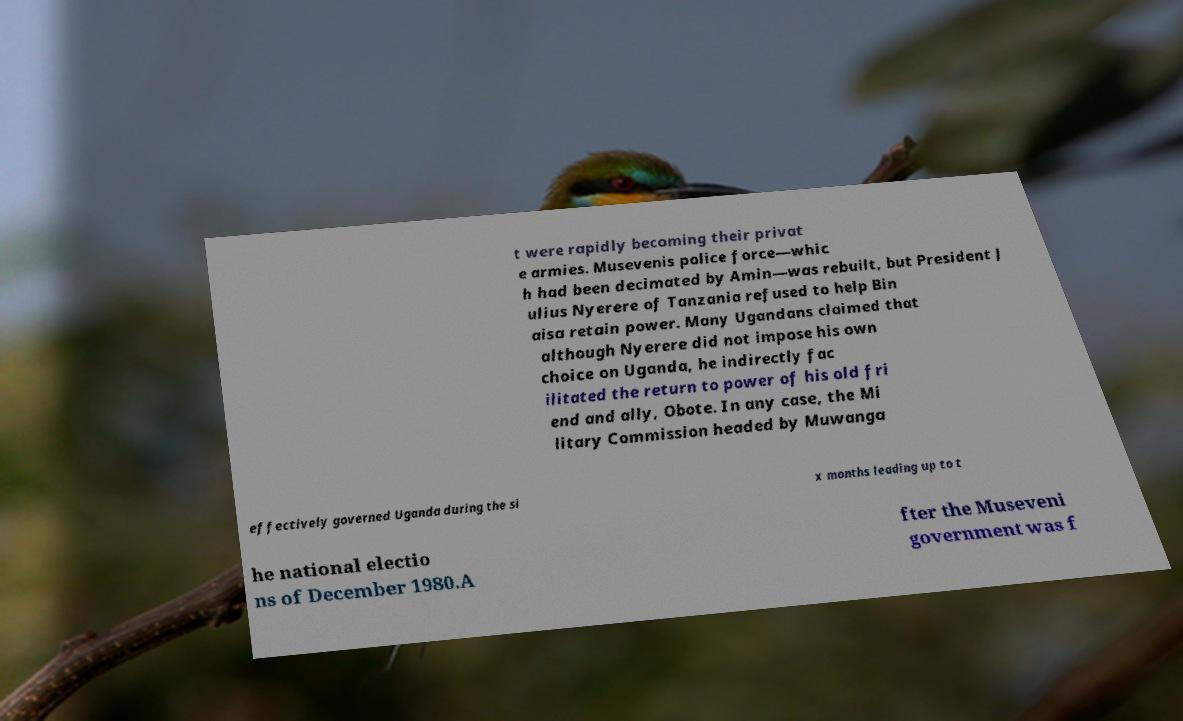Could you assist in decoding the text presented in this image and type it out clearly? t were rapidly becoming their privat e armies. Musevenis police force—whic h had been decimated by Amin—was rebuilt, but President J ulius Nyerere of Tanzania refused to help Bin aisa retain power. Many Ugandans claimed that although Nyerere did not impose his own choice on Uganda, he indirectly fac ilitated the return to power of his old fri end and ally, Obote. In any case, the Mi litary Commission headed by Muwanga effectively governed Uganda during the si x months leading up to t he national electio ns of December 1980.A fter the Museveni government was f 